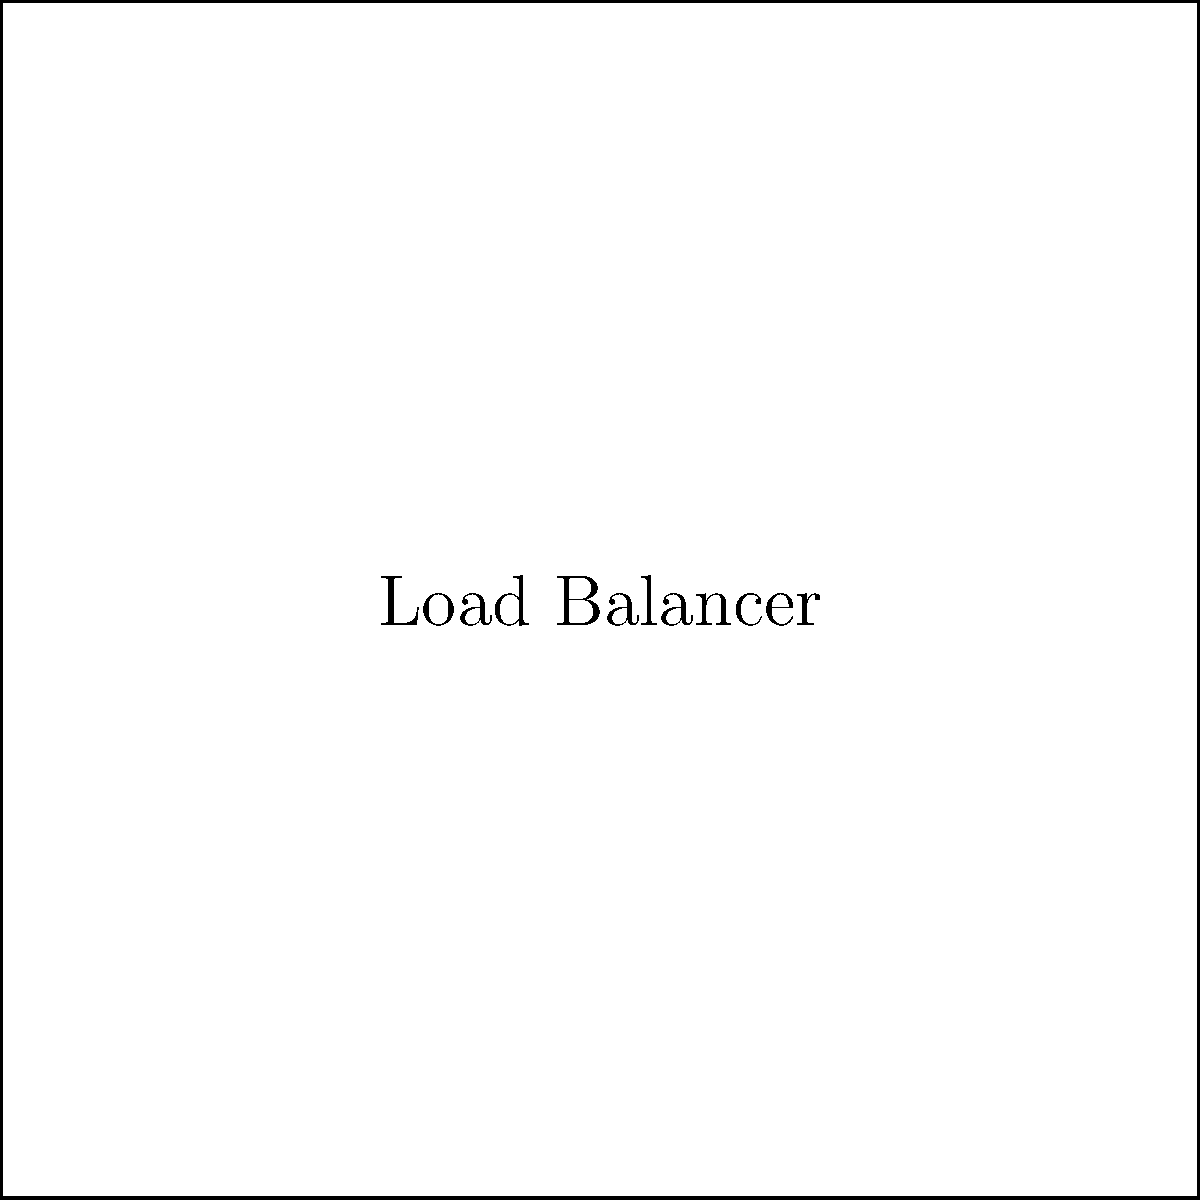In the given load balancing architecture for multiple Tomcat instances, what is the primary purpose of the load balancer, and how does it contribute to improving the overall performance and reliability of the web application? To understand the role of the load balancer in this architecture, let's break it down step-by-step:

1. Load Balancer Function: The load balancer acts as a reverse proxy and distributes incoming network traffic across multiple Tomcat instances.

2. Traffic Distribution: It receives incoming requests and forwards them to one of the available Tomcat servers based on a predefined algorithm (e.g., round-robin, least connections).

3. Improved Performance: By distributing requests across multiple servers, the load balancer prevents any single server from becoming overwhelmed, thus improving overall system performance.

4. High Availability: If one Tomcat instance fails, the load balancer can redirect traffic to the remaining healthy instances, ensuring continued service availability.

5. Scalability: This architecture allows for easy horizontal scaling by adding more Tomcat instances as needed, without changing the application code.

6. Session Persistence: Load balancers can be configured to maintain session persistence, ensuring that a user's requests are always sent to the same Tomcat instance for the duration of their session.

7. SSL Termination: The load balancer can handle SSL/TLS encryption and decryption, offloading this computationally intensive task from the Tomcat servers.

8. Health Checks: Load balancers typically perform regular health checks on the Tomcat instances, removing unhealthy servers from the pool until they recover.

The primary purpose of the load balancer in this architecture is to distribute incoming requests across multiple Tomcat instances, thereby improving performance, ensuring high availability, and enabling scalability of the web application.
Answer: Distribute traffic, improve performance, ensure high availability, and enable scalability. 